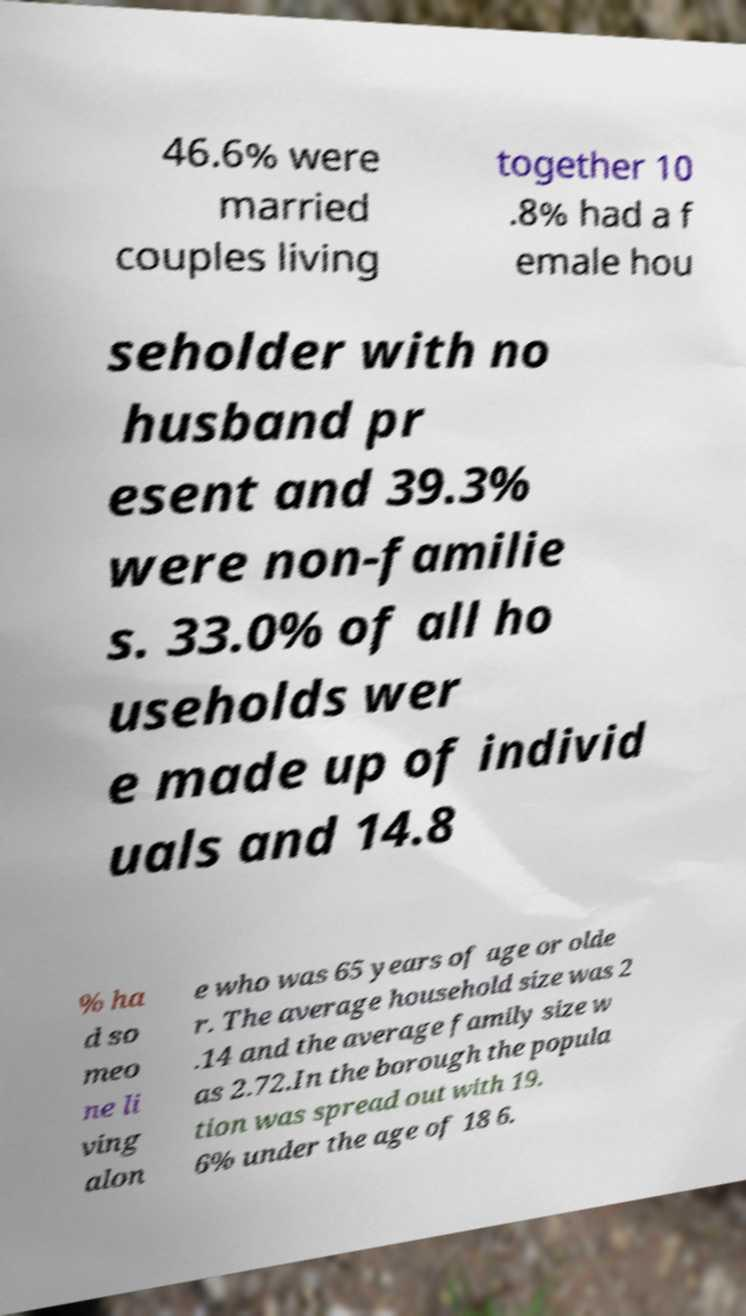Could you extract and type out the text from this image? 46.6% were married couples living together 10 .8% had a f emale hou seholder with no husband pr esent and 39.3% were non-familie s. 33.0% of all ho useholds wer e made up of individ uals and 14.8 % ha d so meo ne li ving alon e who was 65 years of age or olde r. The average household size was 2 .14 and the average family size w as 2.72.In the borough the popula tion was spread out with 19. 6% under the age of 18 6. 